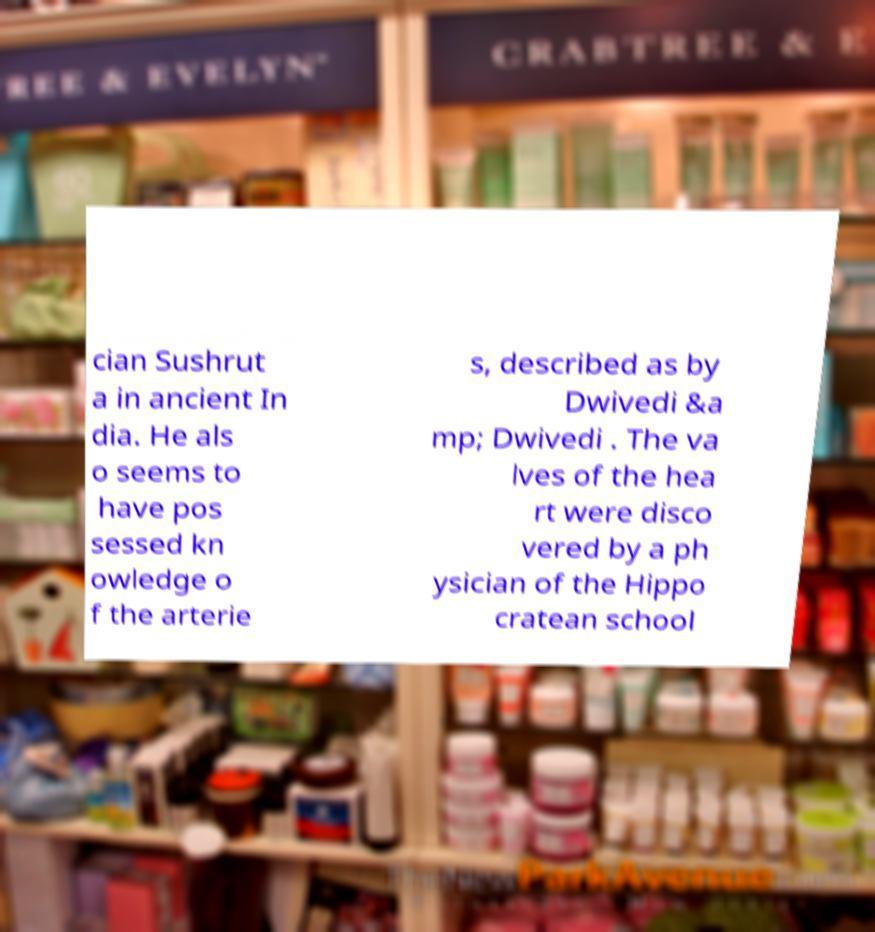I need the written content from this picture converted into text. Can you do that? cian Sushrut a in ancient In dia. He als o seems to have pos sessed kn owledge o f the arterie s, described as by Dwivedi &a mp; Dwivedi . The va lves of the hea rt were disco vered by a ph ysician of the Hippo cratean school 